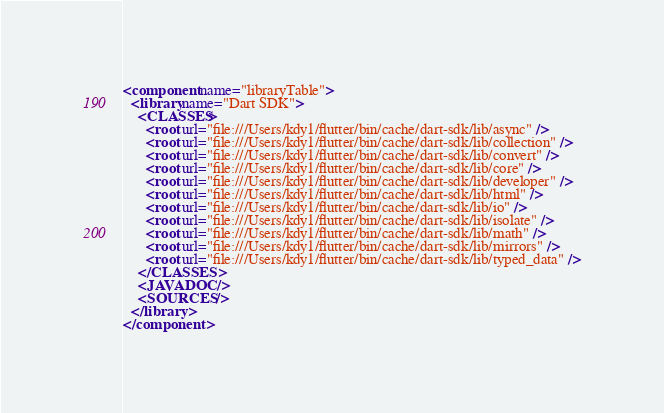<code> <loc_0><loc_0><loc_500><loc_500><_XML_><component name="libraryTable">
  <library name="Dart SDK">
    <CLASSES>
      <root url="file:///Users/kdy1/flutter/bin/cache/dart-sdk/lib/async" />
      <root url="file:///Users/kdy1/flutter/bin/cache/dart-sdk/lib/collection" />
      <root url="file:///Users/kdy1/flutter/bin/cache/dart-sdk/lib/convert" />
      <root url="file:///Users/kdy1/flutter/bin/cache/dart-sdk/lib/core" />
      <root url="file:///Users/kdy1/flutter/bin/cache/dart-sdk/lib/developer" />
      <root url="file:///Users/kdy1/flutter/bin/cache/dart-sdk/lib/html" />
      <root url="file:///Users/kdy1/flutter/bin/cache/dart-sdk/lib/io" />
      <root url="file:///Users/kdy1/flutter/bin/cache/dart-sdk/lib/isolate" />
      <root url="file:///Users/kdy1/flutter/bin/cache/dart-sdk/lib/math" />
      <root url="file:///Users/kdy1/flutter/bin/cache/dart-sdk/lib/mirrors" />
      <root url="file:///Users/kdy1/flutter/bin/cache/dart-sdk/lib/typed_data" />
    </CLASSES>
    <JAVADOC />
    <SOURCES />
  </library>
</component></code> 